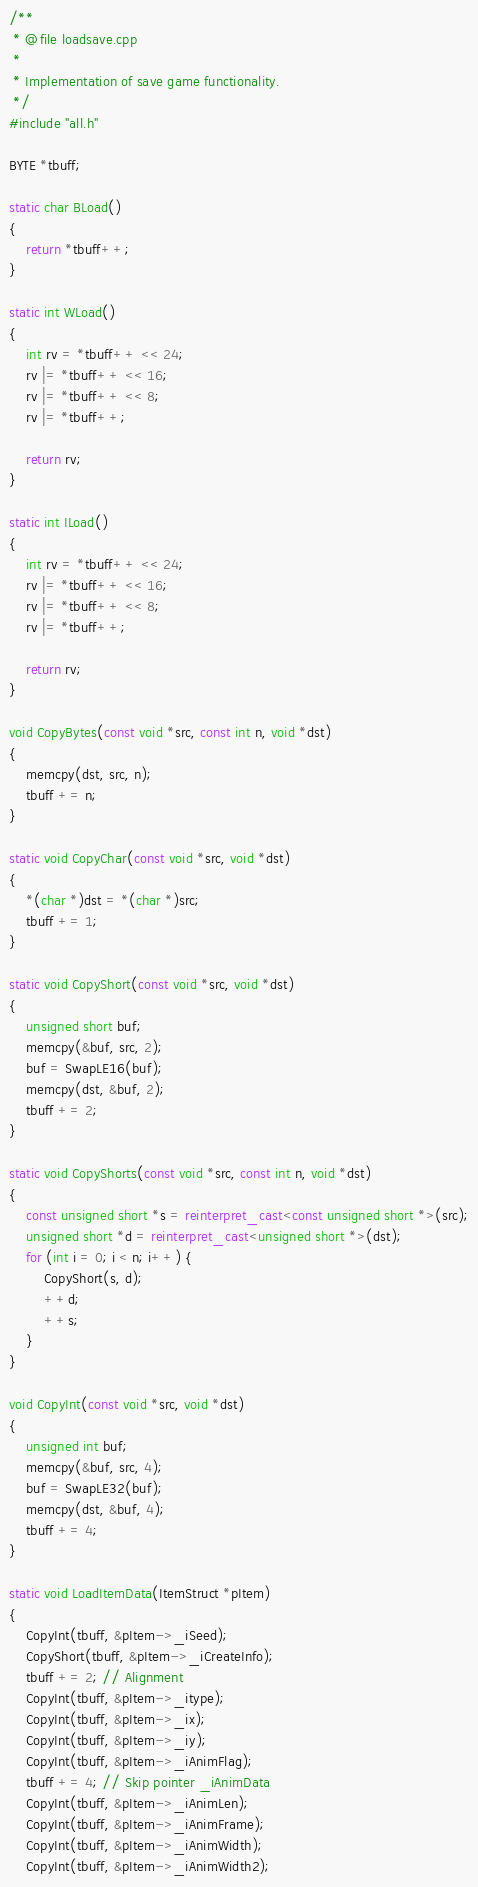Convert code to text. <code><loc_0><loc_0><loc_500><loc_500><_C++_>/**
 * @file loadsave.cpp
 *
 * Implementation of save game functionality.
 */
#include "all.h"

BYTE *tbuff;

static char BLoad()
{
	return *tbuff++;
}

static int WLoad()
{
	int rv = *tbuff++ << 24;
	rv |= *tbuff++ << 16;
	rv |= *tbuff++ << 8;
	rv |= *tbuff++;

	return rv;
}

static int ILoad()
{
	int rv = *tbuff++ << 24;
	rv |= *tbuff++ << 16;
	rv |= *tbuff++ << 8;
	rv |= *tbuff++;

	return rv;
}

void CopyBytes(const void *src, const int n, void *dst)
{
	memcpy(dst, src, n);
	tbuff += n;
}

static void CopyChar(const void *src, void *dst)
{
	*(char *)dst = *(char *)src;
	tbuff += 1;
}

static void CopyShort(const void *src, void *dst)
{
	unsigned short buf;
	memcpy(&buf, src, 2);
	buf = SwapLE16(buf);
	memcpy(dst, &buf, 2);
	tbuff += 2;
}

static void CopyShorts(const void *src, const int n, void *dst)
{
	const unsigned short *s = reinterpret_cast<const unsigned short *>(src);
	unsigned short *d = reinterpret_cast<unsigned short *>(dst);
	for (int i = 0; i < n; i++) {
		CopyShort(s, d);
		++d;
		++s;
	}
}

void CopyInt(const void *src, void *dst)
{
	unsigned int buf;
	memcpy(&buf, src, 4);
	buf = SwapLE32(buf);
	memcpy(dst, &buf, 4);
	tbuff += 4;
}

static void LoadItemData(ItemStruct *pItem)
{
	CopyInt(tbuff, &pItem->_iSeed);
	CopyShort(tbuff, &pItem->_iCreateInfo);
	tbuff += 2; // Alignment
	CopyInt(tbuff, &pItem->_itype);
	CopyInt(tbuff, &pItem->_ix);
	CopyInt(tbuff, &pItem->_iy);
	CopyInt(tbuff, &pItem->_iAnimFlag);
	tbuff += 4; // Skip pointer _iAnimData
	CopyInt(tbuff, &pItem->_iAnimLen);
	CopyInt(tbuff, &pItem->_iAnimFrame);
	CopyInt(tbuff, &pItem->_iAnimWidth);
	CopyInt(tbuff, &pItem->_iAnimWidth2);</code> 